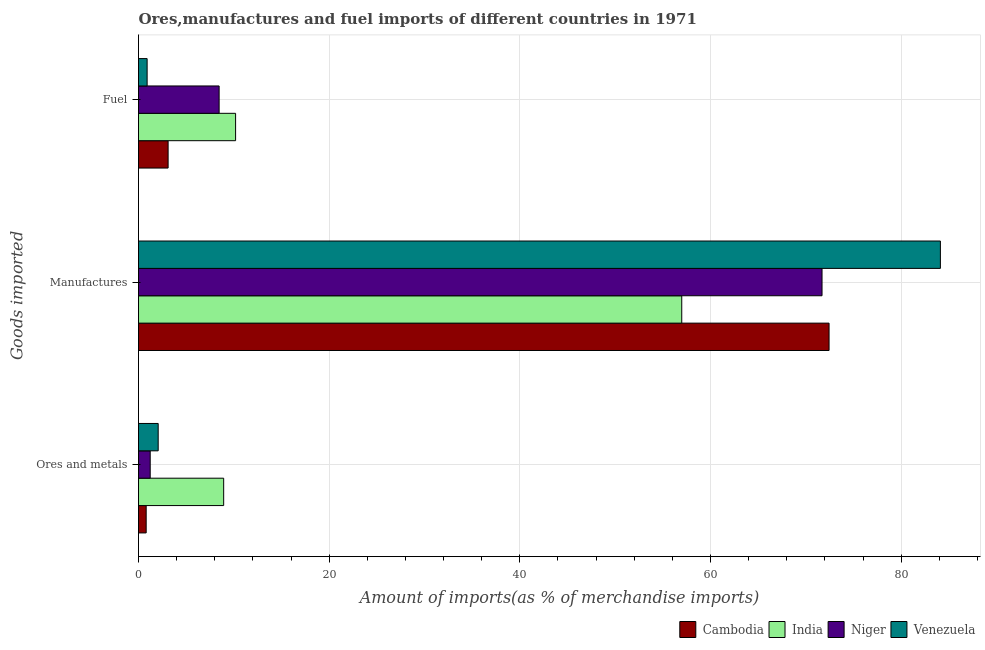How many different coloured bars are there?
Make the answer very short. 4. Are the number of bars per tick equal to the number of legend labels?
Offer a terse response. Yes. Are the number of bars on each tick of the Y-axis equal?
Your answer should be very brief. Yes. What is the label of the 1st group of bars from the top?
Provide a succinct answer. Fuel. What is the percentage of fuel imports in Cambodia?
Your answer should be compact. 3.11. Across all countries, what is the maximum percentage of manufactures imports?
Provide a succinct answer. 84.12. Across all countries, what is the minimum percentage of manufactures imports?
Provide a short and direct response. 56.99. In which country was the percentage of fuel imports minimum?
Give a very brief answer. Venezuela. What is the total percentage of fuel imports in the graph?
Offer a terse response. 22.65. What is the difference between the percentage of fuel imports in Cambodia and that in Niger?
Provide a short and direct response. -5.35. What is the difference between the percentage of ores and metals imports in Cambodia and the percentage of manufactures imports in India?
Give a very brief answer. -56.18. What is the average percentage of manufactures imports per country?
Offer a terse response. 71.31. What is the difference between the percentage of manufactures imports and percentage of ores and metals imports in India?
Offer a terse response. 48.05. In how many countries, is the percentage of ores and metals imports greater than 36 %?
Your response must be concise. 0. What is the ratio of the percentage of fuel imports in Venezuela to that in Cambodia?
Give a very brief answer. 0.29. What is the difference between the highest and the second highest percentage of fuel imports?
Your answer should be very brief. 1.73. What is the difference between the highest and the lowest percentage of ores and metals imports?
Make the answer very short. 8.13. In how many countries, is the percentage of fuel imports greater than the average percentage of fuel imports taken over all countries?
Your answer should be compact. 2. What does the 1st bar from the top in Manufactures represents?
Offer a very short reply. Venezuela. What does the 3rd bar from the bottom in Fuel represents?
Provide a short and direct response. Niger. What is the difference between two consecutive major ticks on the X-axis?
Offer a terse response. 20. Does the graph contain any zero values?
Ensure brevity in your answer.  No. Where does the legend appear in the graph?
Your answer should be very brief. Bottom right. How many legend labels are there?
Your response must be concise. 4. How are the legend labels stacked?
Offer a terse response. Horizontal. What is the title of the graph?
Give a very brief answer. Ores,manufactures and fuel imports of different countries in 1971. Does "Finland" appear as one of the legend labels in the graph?
Keep it short and to the point. No. What is the label or title of the X-axis?
Give a very brief answer. Amount of imports(as % of merchandise imports). What is the label or title of the Y-axis?
Provide a succinct answer. Goods imported. What is the Amount of imports(as % of merchandise imports) in Cambodia in Ores and metals?
Your answer should be very brief. 0.8. What is the Amount of imports(as % of merchandise imports) of India in Ores and metals?
Provide a short and direct response. 8.93. What is the Amount of imports(as % of merchandise imports) of Niger in Ores and metals?
Offer a terse response. 1.23. What is the Amount of imports(as % of merchandise imports) of Venezuela in Ores and metals?
Your response must be concise. 2.06. What is the Amount of imports(as % of merchandise imports) of Cambodia in Manufactures?
Make the answer very short. 72.44. What is the Amount of imports(as % of merchandise imports) in India in Manufactures?
Offer a terse response. 56.99. What is the Amount of imports(as % of merchandise imports) in Niger in Manufactures?
Make the answer very short. 71.7. What is the Amount of imports(as % of merchandise imports) of Venezuela in Manufactures?
Offer a very short reply. 84.12. What is the Amount of imports(as % of merchandise imports) of Cambodia in Fuel?
Offer a very short reply. 3.11. What is the Amount of imports(as % of merchandise imports) of India in Fuel?
Your answer should be very brief. 10.18. What is the Amount of imports(as % of merchandise imports) in Niger in Fuel?
Offer a very short reply. 8.46. What is the Amount of imports(as % of merchandise imports) of Venezuela in Fuel?
Your answer should be very brief. 0.9. Across all Goods imported, what is the maximum Amount of imports(as % of merchandise imports) in Cambodia?
Ensure brevity in your answer.  72.44. Across all Goods imported, what is the maximum Amount of imports(as % of merchandise imports) in India?
Your answer should be very brief. 56.99. Across all Goods imported, what is the maximum Amount of imports(as % of merchandise imports) of Niger?
Your answer should be compact. 71.7. Across all Goods imported, what is the maximum Amount of imports(as % of merchandise imports) of Venezuela?
Make the answer very short. 84.12. Across all Goods imported, what is the minimum Amount of imports(as % of merchandise imports) in Cambodia?
Offer a very short reply. 0.8. Across all Goods imported, what is the minimum Amount of imports(as % of merchandise imports) of India?
Make the answer very short. 8.93. Across all Goods imported, what is the minimum Amount of imports(as % of merchandise imports) of Niger?
Offer a very short reply. 1.23. Across all Goods imported, what is the minimum Amount of imports(as % of merchandise imports) of Venezuela?
Make the answer very short. 0.9. What is the total Amount of imports(as % of merchandise imports) of Cambodia in the graph?
Make the answer very short. 76.35. What is the total Amount of imports(as % of merchandise imports) of India in the graph?
Offer a terse response. 76.11. What is the total Amount of imports(as % of merchandise imports) in Niger in the graph?
Provide a short and direct response. 81.39. What is the total Amount of imports(as % of merchandise imports) in Venezuela in the graph?
Offer a terse response. 87.09. What is the difference between the Amount of imports(as % of merchandise imports) in Cambodia in Ores and metals and that in Manufactures?
Provide a succinct answer. -71.64. What is the difference between the Amount of imports(as % of merchandise imports) in India in Ores and metals and that in Manufactures?
Your response must be concise. -48.05. What is the difference between the Amount of imports(as % of merchandise imports) in Niger in Ores and metals and that in Manufactures?
Provide a succinct answer. -70.48. What is the difference between the Amount of imports(as % of merchandise imports) of Venezuela in Ores and metals and that in Manufactures?
Make the answer very short. -82.06. What is the difference between the Amount of imports(as % of merchandise imports) of Cambodia in Ores and metals and that in Fuel?
Provide a succinct answer. -2.3. What is the difference between the Amount of imports(as % of merchandise imports) in India in Ores and metals and that in Fuel?
Give a very brief answer. -1.25. What is the difference between the Amount of imports(as % of merchandise imports) in Niger in Ores and metals and that in Fuel?
Provide a short and direct response. -7.23. What is the difference between the Amount of imports(as % of merchandise imports) in Venezuela in Ores and metals and that in Fuel?
Your response must be concise. 1.16. What is the difference between the Amount of imports(as % of merchandise imports) of Cambodia in Manufactures and that in Fuel?
Make the answer very short. 69.33. What is the difference between the Amount of imports(as % of merchandise imports) in India in Manufactures and that in Fuel?
Your answer should be very brief. 46.8. What is the difference between the Amount of imports(as % of merchandise imports) of Niger in Manufactures and that in Fuel?
Make the answer very short. 63.25. What is the difference between the Amount of imports(as % of merchandise imports) in Venezuela in Manufactures and that in Fuel?
Give a very brief answer. 83.22. What is the difference between the Amount of imports(as % of merchandise imports) of Cambodia in Ores and metals and the Amount of imports(as % of merchandise imports) of India in Manufactures?
Your response must be concise. -56.18. What is the difference between the Amount of imports(as % of merchandise imports) of Cambodia in Ores and metals and the Amount of imports(as % of merchandise imports) of Niger in Manufactures?
Ensure brevity in your answer.  -70.9. What is the difference between the Amount of imports(as % of merchandise imports) of Cambodia in Ores and metals and the Amount of imports(as % of merchandise imports) of Venezuela in Manufactures?
Make the answer very short. -83.32. What is the difference between the Amount of imports(as % of merchandise imports) of India in Ores and metals and the Amount of imports(as % of merchandise imports) of Niger in Manufactures?
Your response must be concise. -62.77. What is the difference between the Amount of imports(as % of merchandise imports) in India in Ores and metals and the Amount of imports(as % of merchandise imports) in Venezuela in Manufactures?
Provide a short and direct response. -75.19. What is the difference between the Amount of imports(as % of merchandise imports) of Niger in Ores and metals and the Amount of imports(as % of merchandise imports) of Venezuela in Manufactures?
Offer a very short reply. -82.89. What is the difference between the Amount of imports(as % of merchandise imports) of Cambodia in Ores and metals and the Amount of imports(as % of merchandise imports) of India in Fuel?
Your response must be concise. -9.38. What is the difference between the Amount of imports(as % of merchandise imports) in Cambodia in Ores and metals and the Amount of imports(as % of merchandise imports) in Niger in Fuel?
Keep it short and to the point. -7.65. What is the difference between the Amount of imports(as % of merchandise imports) of Cambodia in Ores and metals and the Amount of imports(as % of merchandise imports) of Venezuela in Fuel?
Offer a terse response. -0.1. What is the difference between the Amount of imports(as % of merchandise imports) of India in Ores and metals and the Amount of imports(as % of merchandise imports) of Niger in Fuel?
Give a very brief answer. 0.48. What is the difference between the Amount of imports(as % of merchandise imports) in India in Ores and metals and the Amount of imports(as % of merchandise imports) in Venezuela in Fuel?
Ensure brevity in your answer.  8.03. What is the difference between the Amount of imports(as % of merchandise imports) of Niger in Ores and metals and the Amount of imports(as % of merchandise imports) of Venezuela in Fuel?
Keep it short and to the point. 0.32. What is the difference between the Amount of imports(as % of merchandise imports) of Cambodia in Manufactures and the Amount of imports(as % of merchandise imports) of India in Fuel?
Your answer should be compact. 62.26. What is the difference between the Amount of imports(as % of merchandise imports) of Cambodia in Manufactures and the Amount of imports(as % of merchandise imports) of Niger in Fuel?
Your answer should be very brief. 63.98. What is the difference between the Amount of imports(as % of merchandise imports) in Cambodia in Manufactures and the Amount of imports(as % of merchandise imports) in Venezuela in Fuel?
Your response must be concise. 71.54. What is the difference between the Amount of imports(as % of merchandise imports) in India in Manufactures and the Amount of imports(as % of merchandise imports) in Niger in Fuel?
Provide a short and direct response. 48.53. What is the difference between the Amount of imports(as % of merchandise imports) of India in Manufactures and the Amount of imports(as % of merchandise imports) of Venezuela in Fuel?
Make the answer very short. 56.08. What is the difference between the Amount of imports(as % of merchandise imports) in Niger in Manufactures and the Amount of imports(as % of merchandise imports) in Venezuela in Fuel?
Offer a very short reply. 70.8. What is the average Amount of imports(as % of merchandise imports) of Cambodia per Goods imported?
Offer a very short reply. 25.45. What is the average Amount of imports(as % of merchandise imports) in India per Goods imported?
Ensure brevity in your answer.  25.37. What is the average Amount of imports(as % of merchandise imports) in Niger per Goods imported?
Offer a very short reply. 27.13. What is the average Amount of imports(as % of merchandise imports) of Venezuela per Goods imported?
Your response must be concise. 29.03. What is the difference between the Amount of imports(as % of merchandise imports) in Cambodia and Amount of imports(as % of merchandise imports) in India in Ores and metals?
Give a very brief answer. -8.13. What is the difference between the Amount of imports(as % of merchandise imports) in Cambodia and Amount of imports(as % of merchandise imports) in Niger in Ores and metals?
Provide a short and direct response. -0.42. What is the difference between the Amount of imports(as % of merchandise imports) in Cambodia and Amount of imports(as % of merchandise imports) in Venezuela in Ores and metals?
Provide a short and direct response. -1.26. What is the difference between the Amount of imports(as % of merchandise imports) of India and Amount of imports(as % of merchandise imports) of Niger in Ores and metals?
Keep it short and to the point. 7.71. What is the difference between the Amount of imports(as % of merchandise imports) in India and Amount of imports(as % of merchandise imports) in Venezuela in Ores and metals?
Make the answer very short. 6.87. What is the difference between the Amount of imports(as % of merchandise imports) of Niger and Amount of imports(as % of merchandise imports) of Venezuela in Ores and metals?
Offer a terse response. -0.84. What is the difference between the Amount of imports(as % of merchandise imports) in Cambodia and Amount of imports(as % of merchandise imports) in India in Manufactures?
Your response must be concise. 15.45. What is the difference between the Amount of imports(as % of merchandise imports) of Cambodia and Amount of imports(as % of merchandise imports) of Niger in Manufactures?
Ensure brevity in your answer.  0.74. What is the difference between the Amount of imports(as % of merchandise imports) of Cambodia and Amount of imports(as % of merchandise imports) of Venezuela in Manufactures?
Offer a very short reply. -11.68. What is the difference between the Amount of imports(as % of merchandise imports) of India and Amount of imports(as % of merchandise imports) of Niger in Manufactures?
Provide a short and direct response. -14.72. What is the difference between the Amount of imports(as % of merchandise imports) in India and Amount of imports(as % of merchandise imports) in Venezuela in Manufactures?
Provide a short and direct response. -27.13. What is the difference between the Amount of imports(as % of merchandise imports) in Niger and Amount of imports(as % of merchandise imports) in Venezuela in Manufactures?
Provide a short and direct response. -12.42. What is the difference between the Amount of imports(as % of merchandise imports) of Cambodia and Amount of imports(as % of merchandise imports) of India in Fuel?
Offer a very short reply. -7.08. What is the difference between the Amount of imports(as % of merchandise imports) in Cambodia and Amount of imports(as % of merchandise imports) in Niger in Fuel?
Offer a very short reply. -5.35. What is the difference between the Amount of imports(as % of merchandise imports) in Cambodia and Amount of imports(as % of merchandise imports) in Venezuela in Fuel?
Offer a very short reply. 2.2. What is the difference between the Amount of imports(as % of merchandise imports) of India and Amount of imports(as % of merchandise imports) of Niger in Fuel?
Your answer should be very brief. 1.73. What is the difference between the Amount of imports(as % of merchandise imports) in India and Amount of imports(as % of merchandise imports) in Venezuela in Fuel?
Offer a terse response. 9.28. What is the difference between the Amount of imports(as % of merchandise imports) of Niger and Amount of imports(as % of merchandise imports) of Venezuela in Fuel?
Offer a very short reply. 7.55. What is the ratio of the Amount of imports(as % of merchandise imports) in Cambodia in Ores and metals to that in Manufactures?
Your answer should be compact. 0.01. What is the ratio of the Amount of imports(as % of merchandise imports) of India in Ores and metals to that in Manufactures?
Your response must be concise. 0.16. What is the ratio of the Amount of imports(as % of merchandise imports) in Niger in Ores and metals to that in Manufactures?
Provide a short and direct response. 0.02. What is the ratio of the Amount of imports(as % of merchandise imports) in Venezuela in Ores and metals to that in Manufactures?
Keep it short and to the point. 0.02. What is the ratio of the Amount of imports(as % of merchandise imports) in Cambodia in Ores and metals to that in Fuel?
Give a very brief answer. 0.26. What is the ratio of the Amount of imports(as % of merchandise imports) of India in Ores and metals to that in Fuel?
Provide a succinct answer. 0.88. What is the ratio of the Amount of imports(as % of merchandise imports) of Niger in Ores and metals to that in Fuel?
Offer a terse response. 0.14. What is the ratio of the Amount of imports(as % of merchandise imports) of Venezuela in Ores and metals to that in Fuel?
Provide a short and direct response. 2.28. What is the ratio of the Amount of imports(as % of merchandise imports) of Cambodia in Manufactures to that in Fuel?
Keep it short and to the point. 23.32. What is the ratio of the Amount of imports(as % of merchandise imports) in India in Manufactures to that in Fuel?
Your answer should be compact. 5.6. What is the ratio of the Amount of imports(as % of merchandise imports) in Niger in Manufactures to that in Fuel?
Your answer should be very brief. 8.48. What is the ratio of the Amount of imports(as % of merchandise imports) in Venezuela in Manufactures to that in Fuel?
Keep it short and to the point. 93.11. What is the difference between the highest and the second highest Amount of imports(as % of merchandise imports) of Cambodia?
Your answer should be very brief. 69.33. What is the difference between the highest and the second highest Amount of imports(as % of merchandise imports) in India?
Your response must be concise. 46.8. What is the difference between the highest and the second highest Amount of imports(as % of merchandise imports) in Niger?
Your response must be concise. 63.25. What is the difference between the highest and the second highest Amount of imports(as % of merchandise imports) of Venezuela?
Provide a succinct answer. 82.06. What is the difference between the highest and the lowest Amount of imports(as % of merchandise imports) of Cambodia?
Provide a succinct answer. 71.64. What is the difference between the highest and the lowest Amount of imports(as % of merchandise imports) of India?
Ensure brevity in your answer.  48.05. What is the difference between the highest and the lowest Amount of imports(as % of merchandise imports) of Niger?
Offer a terse response. 70.48. What is the difference between the highest and the lowest Amount of imports(as % of merchandise imports) of Venezuela?
Your answer should be compact. 83.22. 